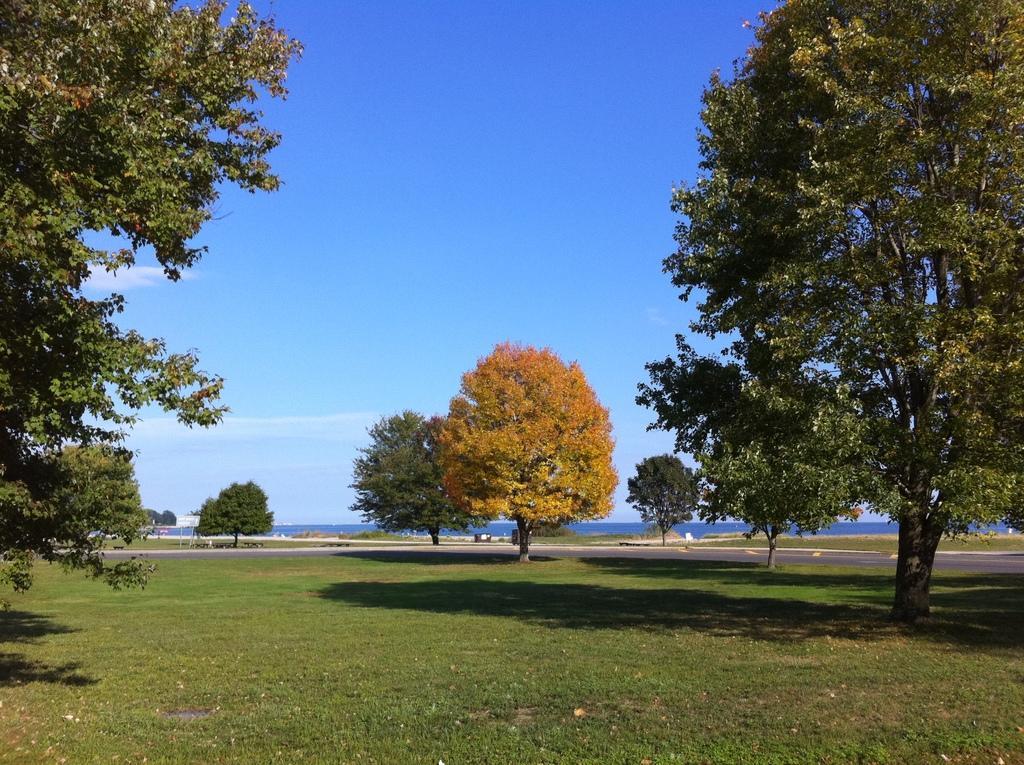Can you describe this image briefly? In this image, there are trees and grass. In the background, we can see water, plants, boards, road, few objects and the sky. 